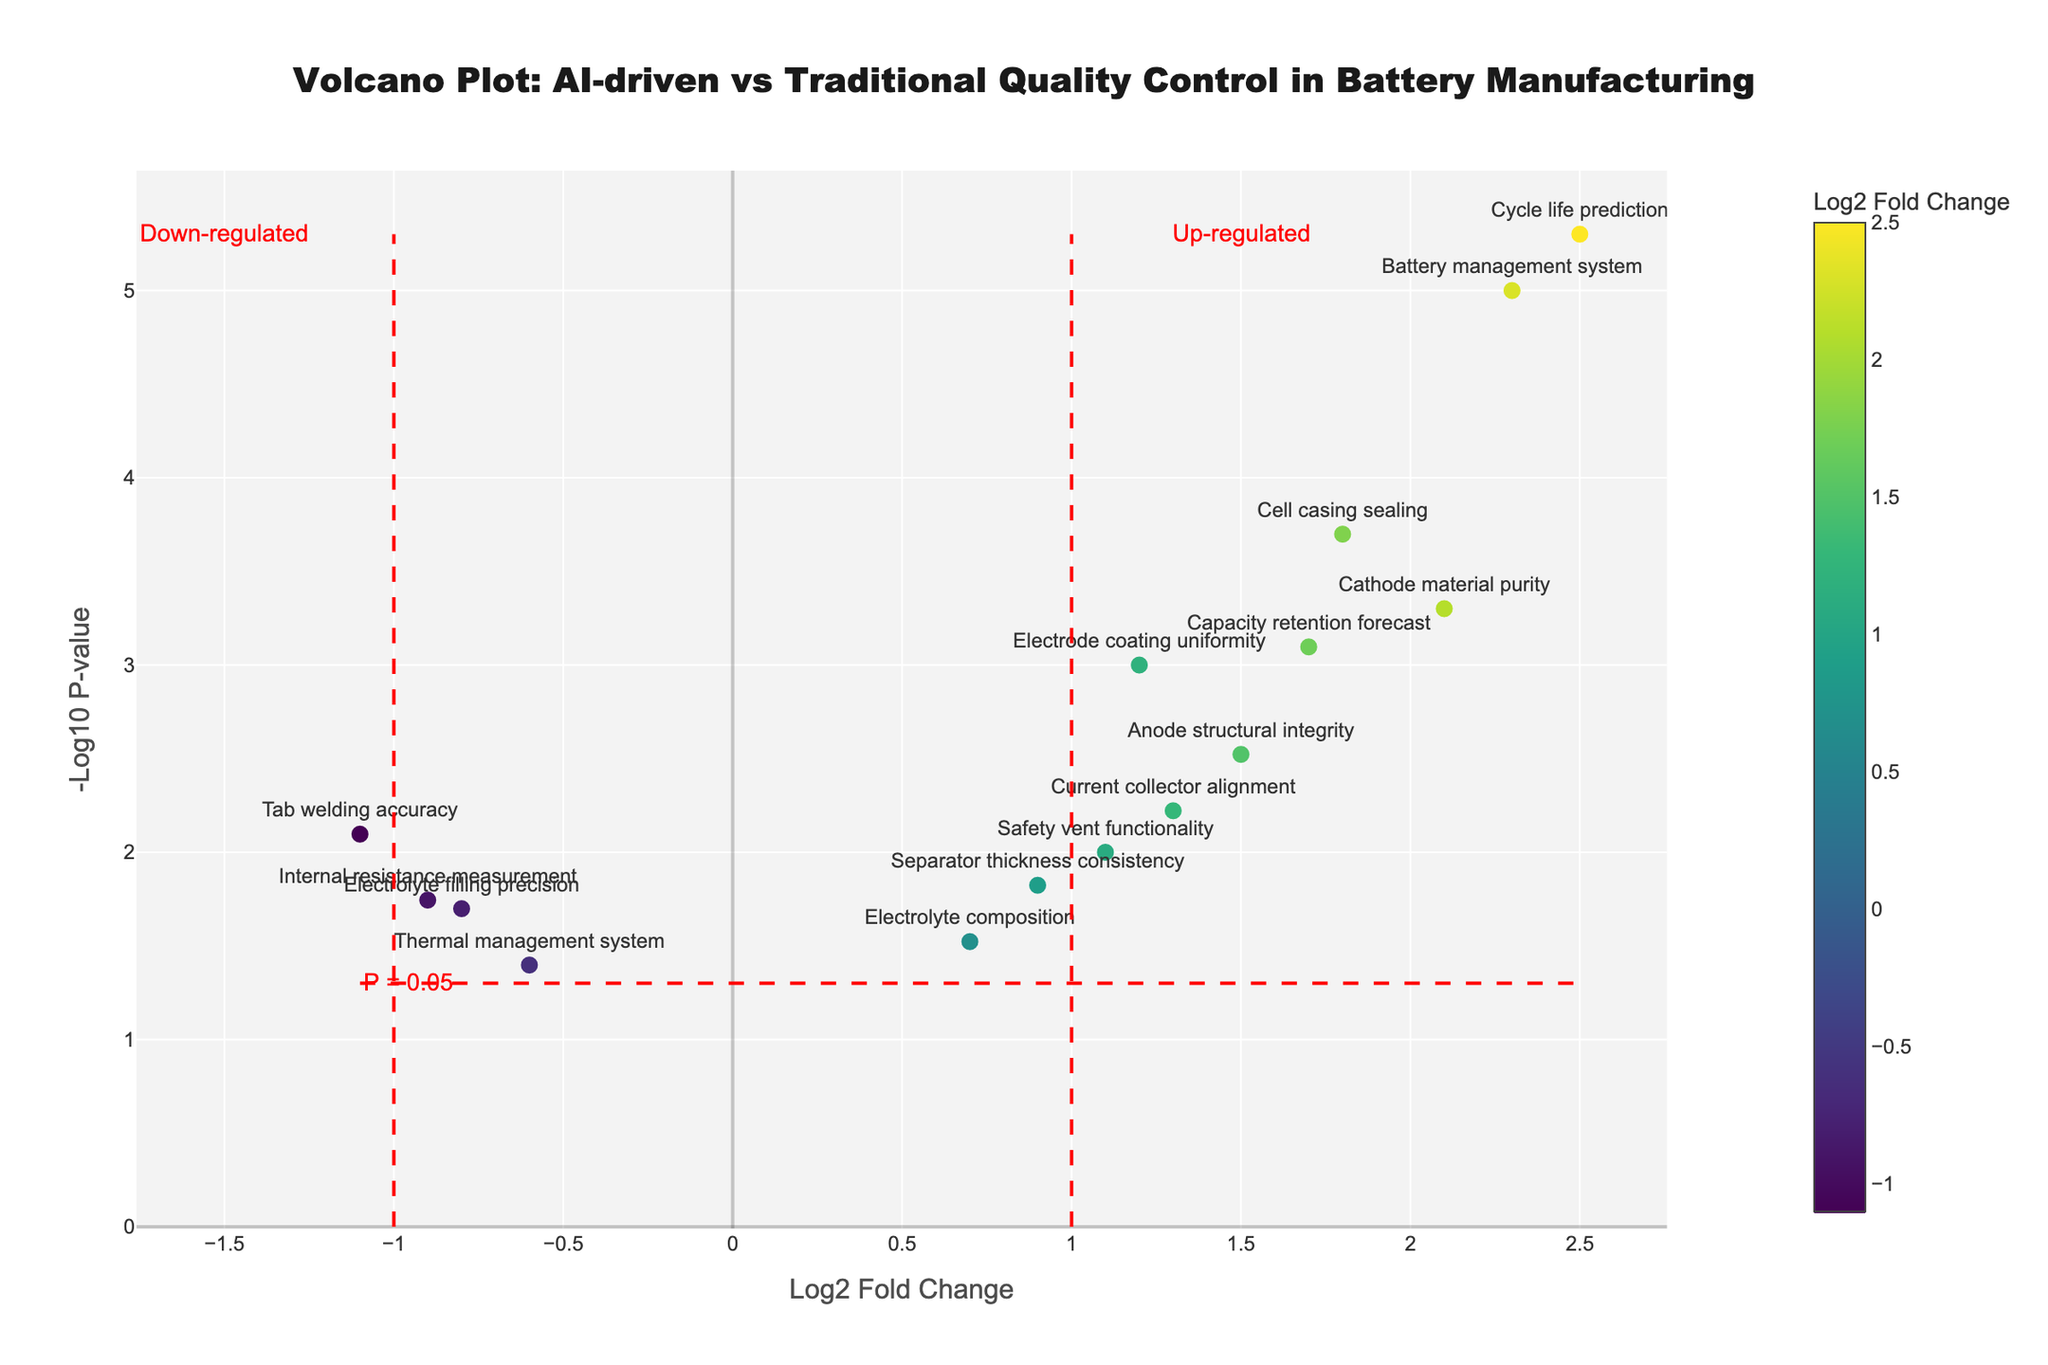What is the title of the figure? The title is located at the top of the figure and reads "Volcano Plot: AI-driven vs Traditional Quality Control in Battery Manufacturing." This provides context about the comparative analysis between AI-driven and traditional quality control systems in battery manufacturing.
Answer: Volcano Plot: AI-driven vs Traditional Quality Control in Battery Manufacturing How many components have a log2 fold change greater than 1? Identify the components with log2 fold change values greater than 1 by checking the x-axis of the plot. There are six such components: Electrode coating uniformity, Cathode material purity, Anode structural integrity, Cell casing sealing, Battery management system, Cycle life prediction, and Capacity retention forecast.
Answer: Six Which component shows the highest statistical significance according to the plot? The highest statistical significance is indicated by the most negative log10 p-value, which corresponds to the highest point on the y-axis. This component is the "Battery management system" because it has the highest -log10 p-value.
Answer: Battery management system Are there any components that are significantly down-regulated? Significantly down-regulated components are those that have a log2 fold change less than -1 and a -log10 p-value greater than the threshold line (p-value <= 0.05). From the plot, the component "Tab welding accuracy" falls into this category.
Answer: Yes, Tab welding accuracy What is the log2 fold change and p-value for the "Electrolyte filling precision"? Locate the "Electrolyte filling precision" on the plot to find its log2 fold change on the x-axis and its p-value as demonstrated by its y-axis position. The log2 fold change is -0.8 and the p-value is 0.02.
Answer: Log2 fold change: -0.8, P-value: 0.02 Which component has the highest log2 fold change? Locate the component that is farthest to the right on the x-axis. The "Cycle life prediction" component has the highest log2 fold change of 2.5.
Answer: Cycle life prediction How many components have p-values below the significance threshold (p = 0.05)? Components with p-values below the significance threshold have points above the horizontal red dashed line representing -log10(0.05) ~ 1.301. Count the points above this threshold. There are thirteen such components.
Answer: Thirteen Which components show a log2 fold change between -1 and 1 and are below the p-value significance threshold? Identify points within the log2 fold change range (-1 to 1) on the x-axis and below the threshold line of -log10(0.05) on the y-axis. These components are "Electrolyte filling precision," "Thermal management system," "Electrolyte composition," and "Internal resistance measurement."
Answer: Electrolyte filling precision, Thermal management system, Electrolyte composition, Internal resistance measurement 